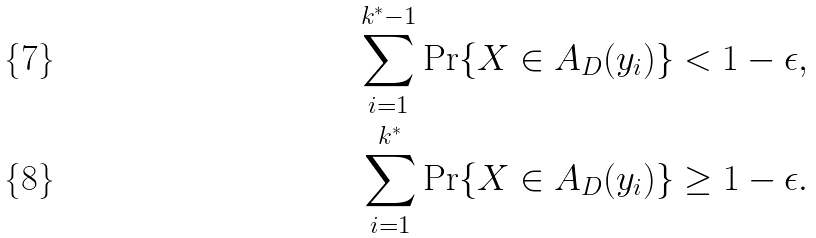Convert formula to latex. <formula><loc_0><loc_0><loc_500><loc_500>\sum _ { i = 1 } ^ { k ^ { * } - 1 } \Pr \{ X \in A _ { D } ( y _ { i } ) \} & < 1 - \epsilon , \\ \sum _ { i = 1 } ^ { k ^ { * } } \Pr \{ X \in A _ { D } ( y _ { i } ) \} & \geq 1 - \epsilon .</formula> 